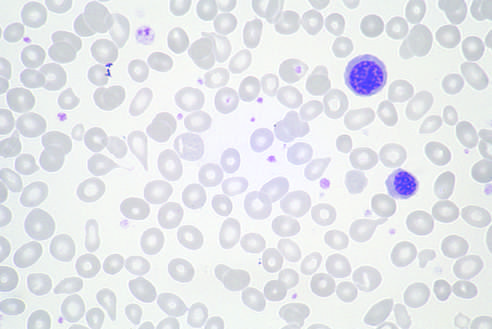what were present in other fields?
Answer the question using a single word or phrase. Immature myeloid cells 